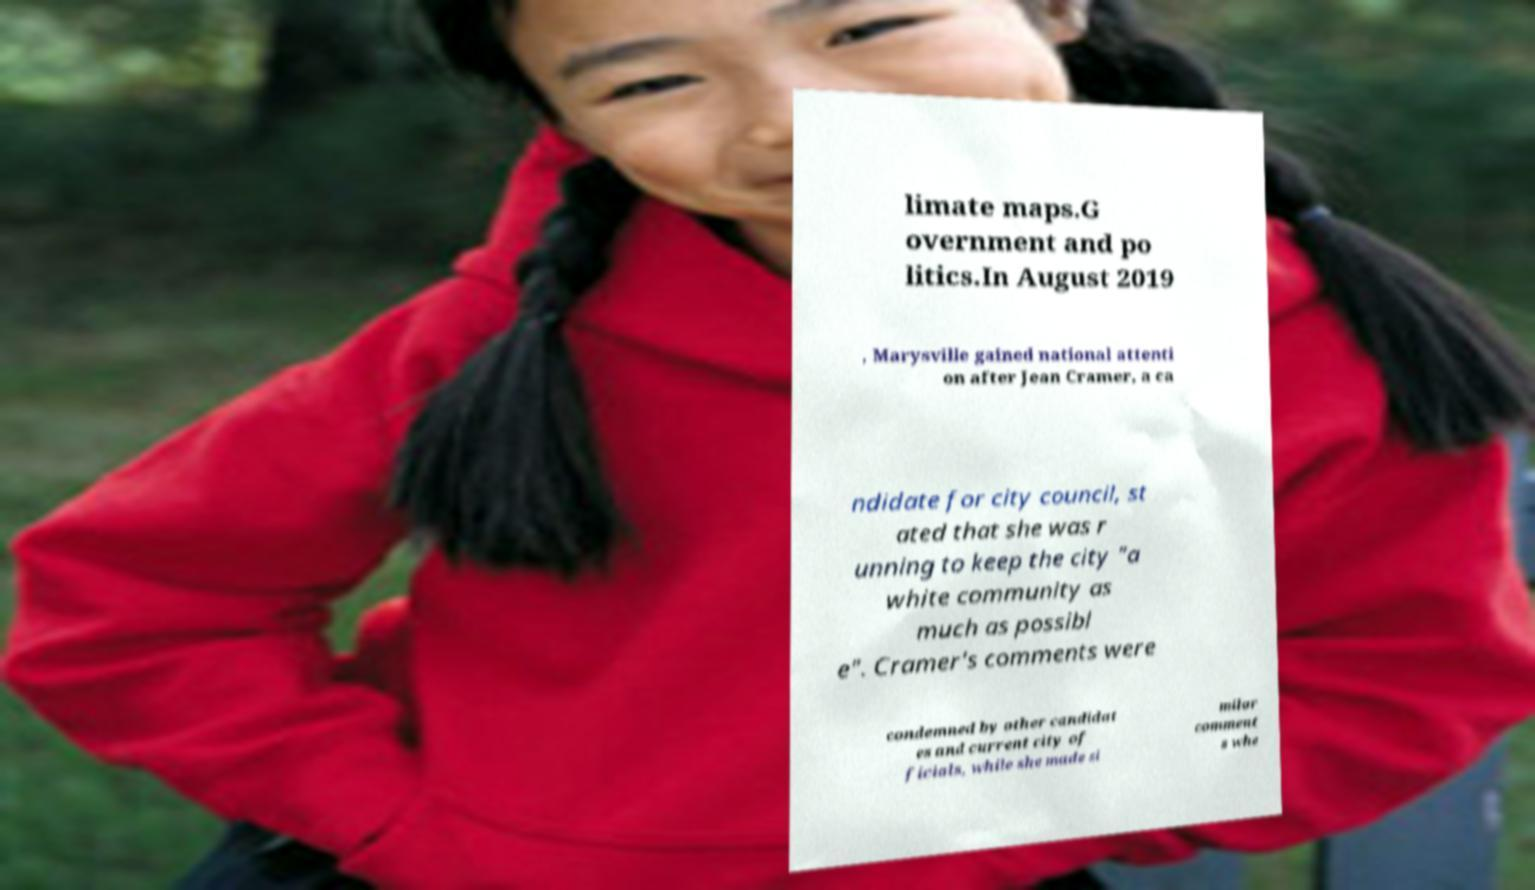Could you assist in decoding the text presented in this image and type it out clearly? limate maps.G overnment and po litics.In August 2019 , Marysville gained national attenti on after Jean Cramer, a ca ndidate for city council, st ated that she was r unning to keep the city "a white community as much as possibl e". Cramer's comments were condemned by other candidat es and current city of ficials, while she made si milar comment s whe 